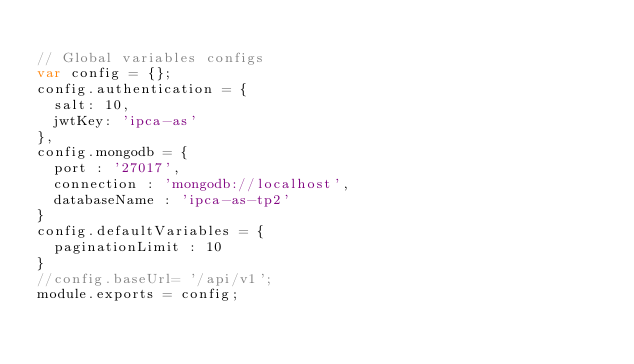<code> <loc_0><loc_0><loc_500><loc_500><_JavaScript_>
// Global variables configs
var config = {};
config.authentication = {
  salt: 10,
  jwtKey: 'ipca-as'
},
config.mongodb = {
  port : '27017',
  connection : 'mongodb://localhost',
  databaseName : 'ipca-as-tp2'
}
config.defaultVariables = {
  paginationLimit : 10
}
//config.baseUrl= '/api/v1';
module.exports = config;
</code> 